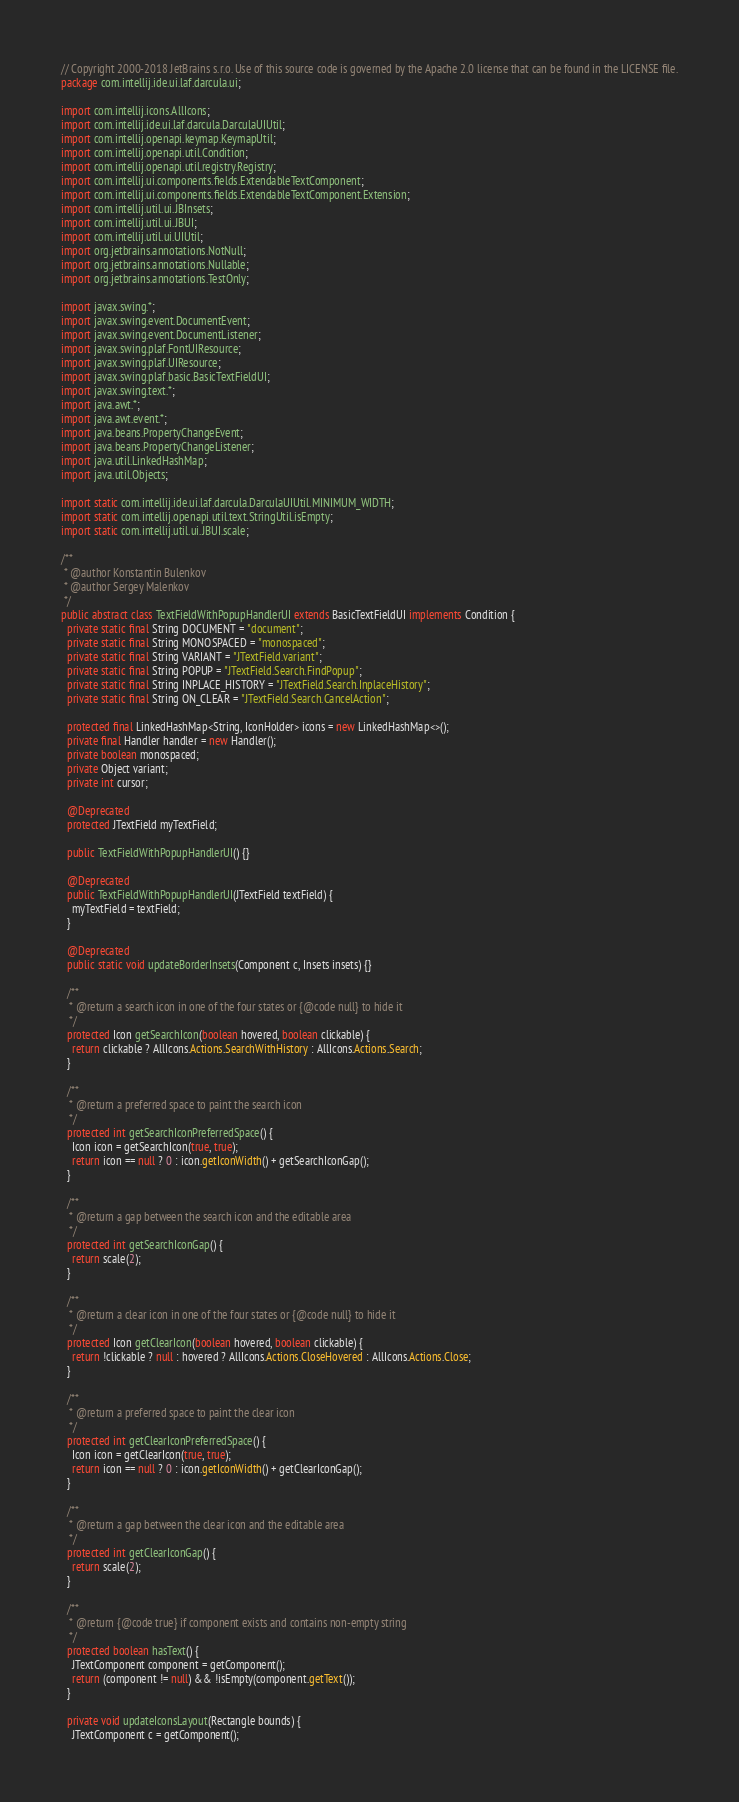<code> <loc_0><loc_0><loc_500><loc_500><_Java_>// Copyright 2000-2018 JetBrains s.r.o. Use of this source code is governed by the Apache 2.0 license that can be found in the LICENSE file.
package com.intellij.ide.ui.laf.darcula.ui;

import com.intellij.icons.AllIcons;
import com.intellij.ide.ui.laf.darcula.DarculaUIUtil;
import com.intellij.openapi.keymap.KeymapUtil;
import com.intellij.openapi.util.Condition;
import com.intellij.openapi.util.registry.Registry;
import com.intellij.ui.components.fields.ExtendableTextComponent;
import com.intellij.ui.components.fields.ExtendableTextComponent.Extension;
import com.intellij.util.ui.JBInsets;
import com.intellij.util.ui.JBUI;
import com.intellij.util.ui.UIUtil;
import org.jetbrains.annotations.NotNull;
import org.jetbrains.annotations.Nullable;
import org.jetbrains.annotations.TestOnly;

import javax.swing.*;
import javax.swing.event.DocumentEvent;
import javax.swing.event.DocumentListener;
import javax.swing.plaf.FontUIResource;
import javax.swing.plaf.UIResource;
import javax.swing.plaf.basic.BasicTextFieldUI;
import javax.swing.text.*;
import java.awt.*;
import java.awt.event.*;
import java.beans.PropertyChangeEvent;
import java.beans.PropertyChangeListener;
import java.util.LinkedHashMap;
import java.util.Objects;

import static com.intellij.ide.ui.laf.darcula.DarculaUIUtil.MINIMUM_WIDTH;
import static com.intellij.openapi.util.text.StringUtil.isEmpty;
import static com.intellij.util.ui.JBUI.scale;

/**
 * @author Konstantin Bulenkov
 * @author Sergey Malenkov
 */
public abstract class TextFieldWithPopupHandlerUI extends BasicTextFieldUI implements Condition {
  private static final String DOCUMENT = "document";
  private static final String MONOSPACED = "monospaced";
  private static final String VARIANT = "JTextField.variant";
  private static final String POPUP = "JTextField.Search.FindPopup";
  private static final String INPLACE_HISTORY = "JTextField.Search.InplaceHistory";
  private static final String ON_CLEAR = "JTextField.Search.CancelAction";

  protected final LinkedHashMap<String, IconHolder> icons = new LinkedHashMap<>();
  private final Handler handler = new Handler();
  private boolean monospaced;
  private Object variant;
  private int cursor;

  @Deprecated
  protected JTextField myTextField;

  public TextFieldWithPopupHandlerUI() {}

  @Deprecated
  public TextFieldWithPopupHandlerUI(JTextField textField) {
    myTextField = textField;
  }

  @Deprecated
  public static void updateBorderInsets(Component c, Insets insets) {}

  /**
   * @return a search icon in one of the four states or {@code null} to hide it
   */
  protected Icon getSearchIcon(boolean hovered, boolean clickable) {
    return clickable ? AllIcons.Actions.SearchWithHistory : AllIcons.Actions.Search;
  }

  /**
   * @return a preferred space to paint the search icon
   */
  protected int getSearchIconPreferredSpace() {
    Icon icon = getSearchIcon(true, true);
    return icon == null ? 0 : icon.getIconWidth() + getSearchIconGap();
  }

  /**
   * @return a gap between the search icon and the editable area
   */
  protected int getSearchIconGap() {
    return scale(2);
  }

  /**
   * @return a clear icon in one of the four states or {@code null} to hide it
   */
  protected Icon getClearIcon(boolean hovered, boolean clickable) {
    return !clickable ? null : hovered ? AllIcons.Actions.CloseHovered : AllIcons.Actions.Close;
  }

  /**
   * @return a preferred space to paint the clear icon
   */
  protected int getClearIconPreferredSpace() {
    Icon icon = getClearIcon(true, true);
    return icon == null ? 0 : icon.getIconWidth() + getClearIconGap();
  }

  /**
   * @return a gap between the clear icon and the editable area
   */
  protected int getClearIconGap() {
    return scale(2);
  }

  /**
   * @return {@code true} if component exists and contains non-empty string
   */
  protected boolean hasText() {
    JTextComponent component = getComponent();
    return (component != null) && !isEmpty(component.getText());
  }

  private void updateIconsLayout(Rectangle bounds) {
    JTextComponent c = getComponent();</code> 